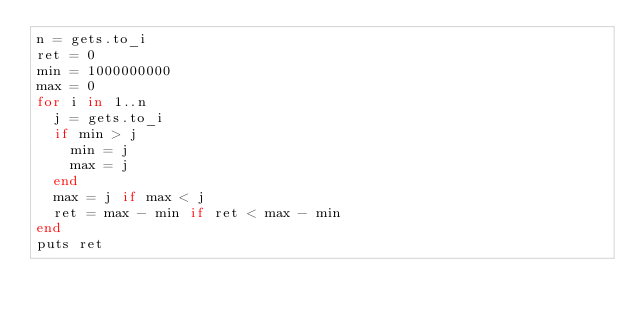Convert code to text. <code><loc_0><loc_0><loc_500><loc_500><_Ruby_>n = gets.to_i
ret = 0
min = 1000000000
max = 0
for i in 1..n
  j = gets.to_i
  if min > j
    min = j
    max = j
  end
  max = j if max < j
  ret = max - min if ret < max - min
end
puts ret</code> 